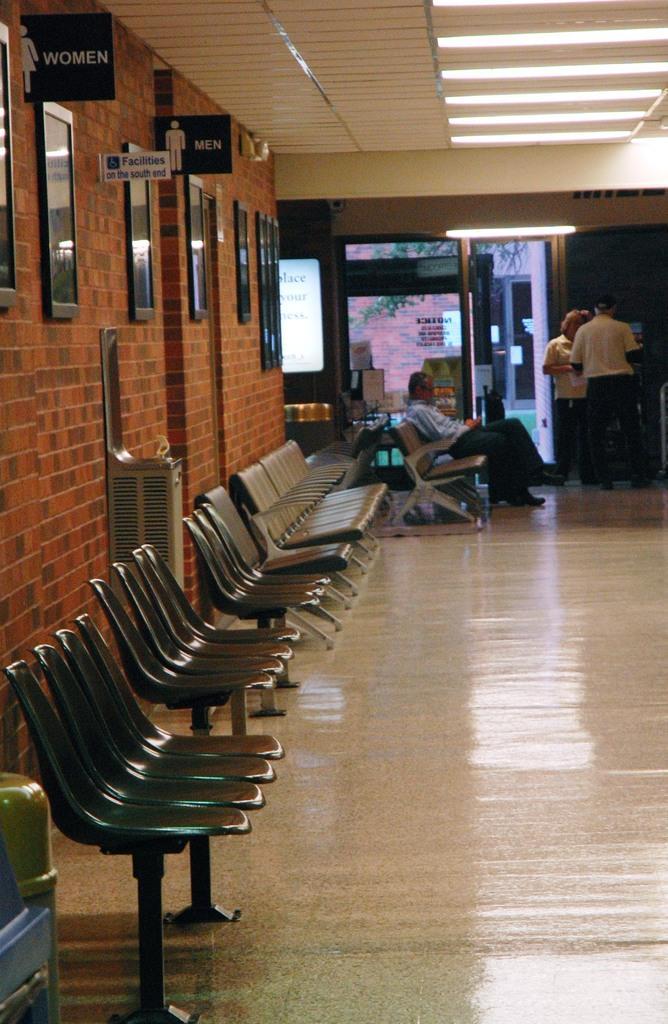Can you describe this image briefly? In this picture there is a man who is wearing shirt, trouser and shoe. He is sitting on the chair, besides him there are two persons were standing near to the door and table. In the bottom left corner I can see the dustbin near to the black chairs. On the left I can see the frames & sign boards on the brick wall. In the background I can see the door, window and tree. In the top right corner I can see the tube lights on the roof. 